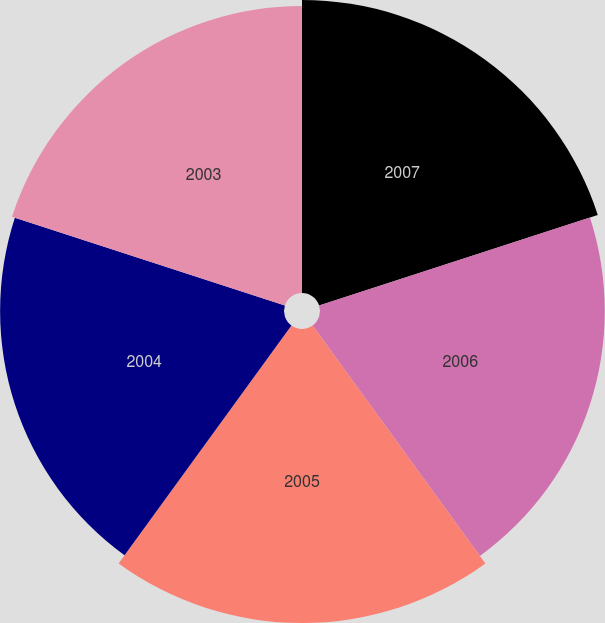Convert chart. <chart><loc_0><loc_0><loc_500><loc_500><pie_chart><fcel>2007<fcel>2006<fcel>2005<fcel>2004<fcel>2003<nl><fcel>20.31%<fcel>19.74%<fcel>20.38%<fcel>19.68%<fcel>19.89%<nl></chart> 